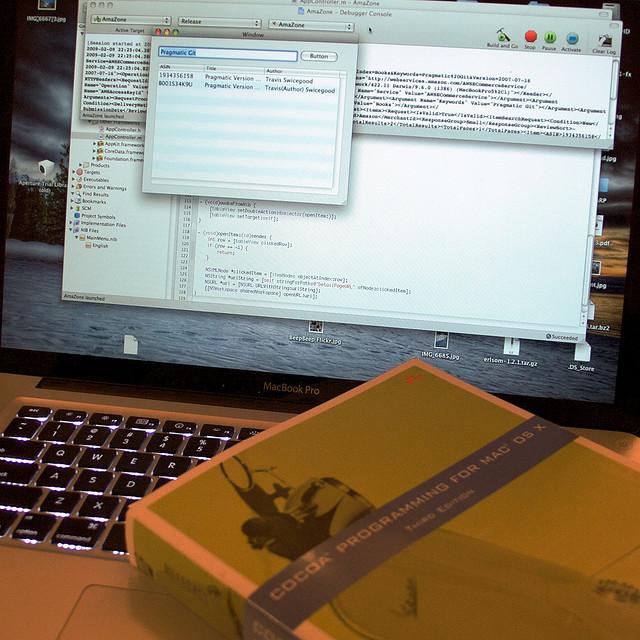Is this an Apple computer?
Give a very brief answer. Yes. What letters are the man typing?
Answer briefly. English. Is this a desktop computer?
Give a very brief answer. Yes. What program is showing on the screen?
Write a very short answer. Email. Are there any handwritten pages in the scene?
Keep it brief. No. 